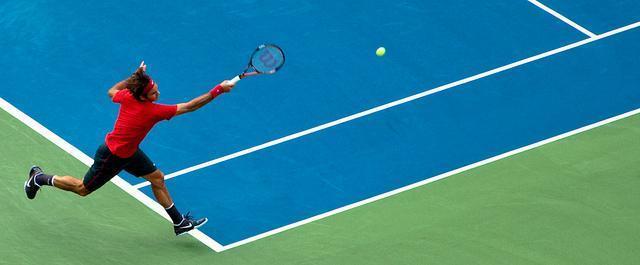How many people are there?
Give a very brief answer. 1. 